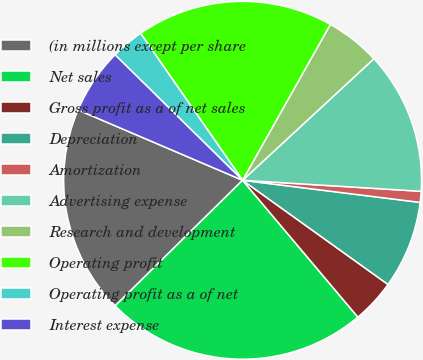Convert chart. <chart><loc_0><loc_0><loc_500><loc_500><pie_chart><fcel>(in millions except per share<fcel>Net sales<fcel>Gross profit as a of net sales<fcel>Depreciation<fcel>Amortization<fcel>Advertising expense<fcel>Research and development<fcel>Operating profit<fcel>Operating profit as a of net<fcel>Interest expense<nl><fcel>18.81%<fcel>23.76%<fcel>3.96%<fcel>7.92%<fcel>0.99%<fcel>12.87%<fcel>4.95%<fcel>17.82%<fcel>2.97%<fcel>5.94%<nl></chart> 